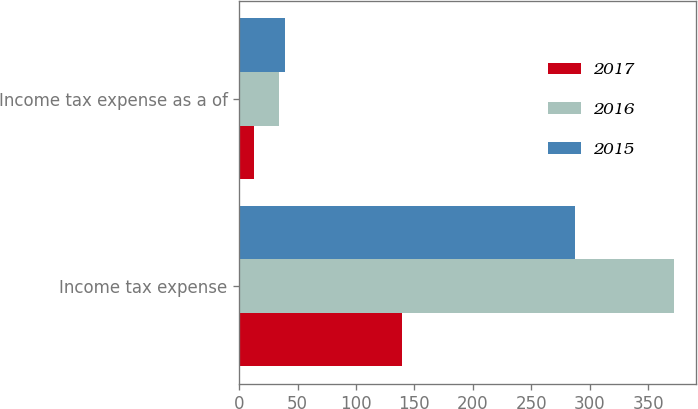Convert chart. <chart><loc_0><loc_0><loc_500><loc_500><stacked_bar_chart><ecel><fcel>Income tax expense<fcel>Income tax expense as a of<nl><fcel>2017<fcel>139.1<fcel>12.3<nl><fcel>2016<fcel>372.3<fcel>33.7<nl><fcel>2015<fcel>287.3<fcel>39.6<nl></chart> 